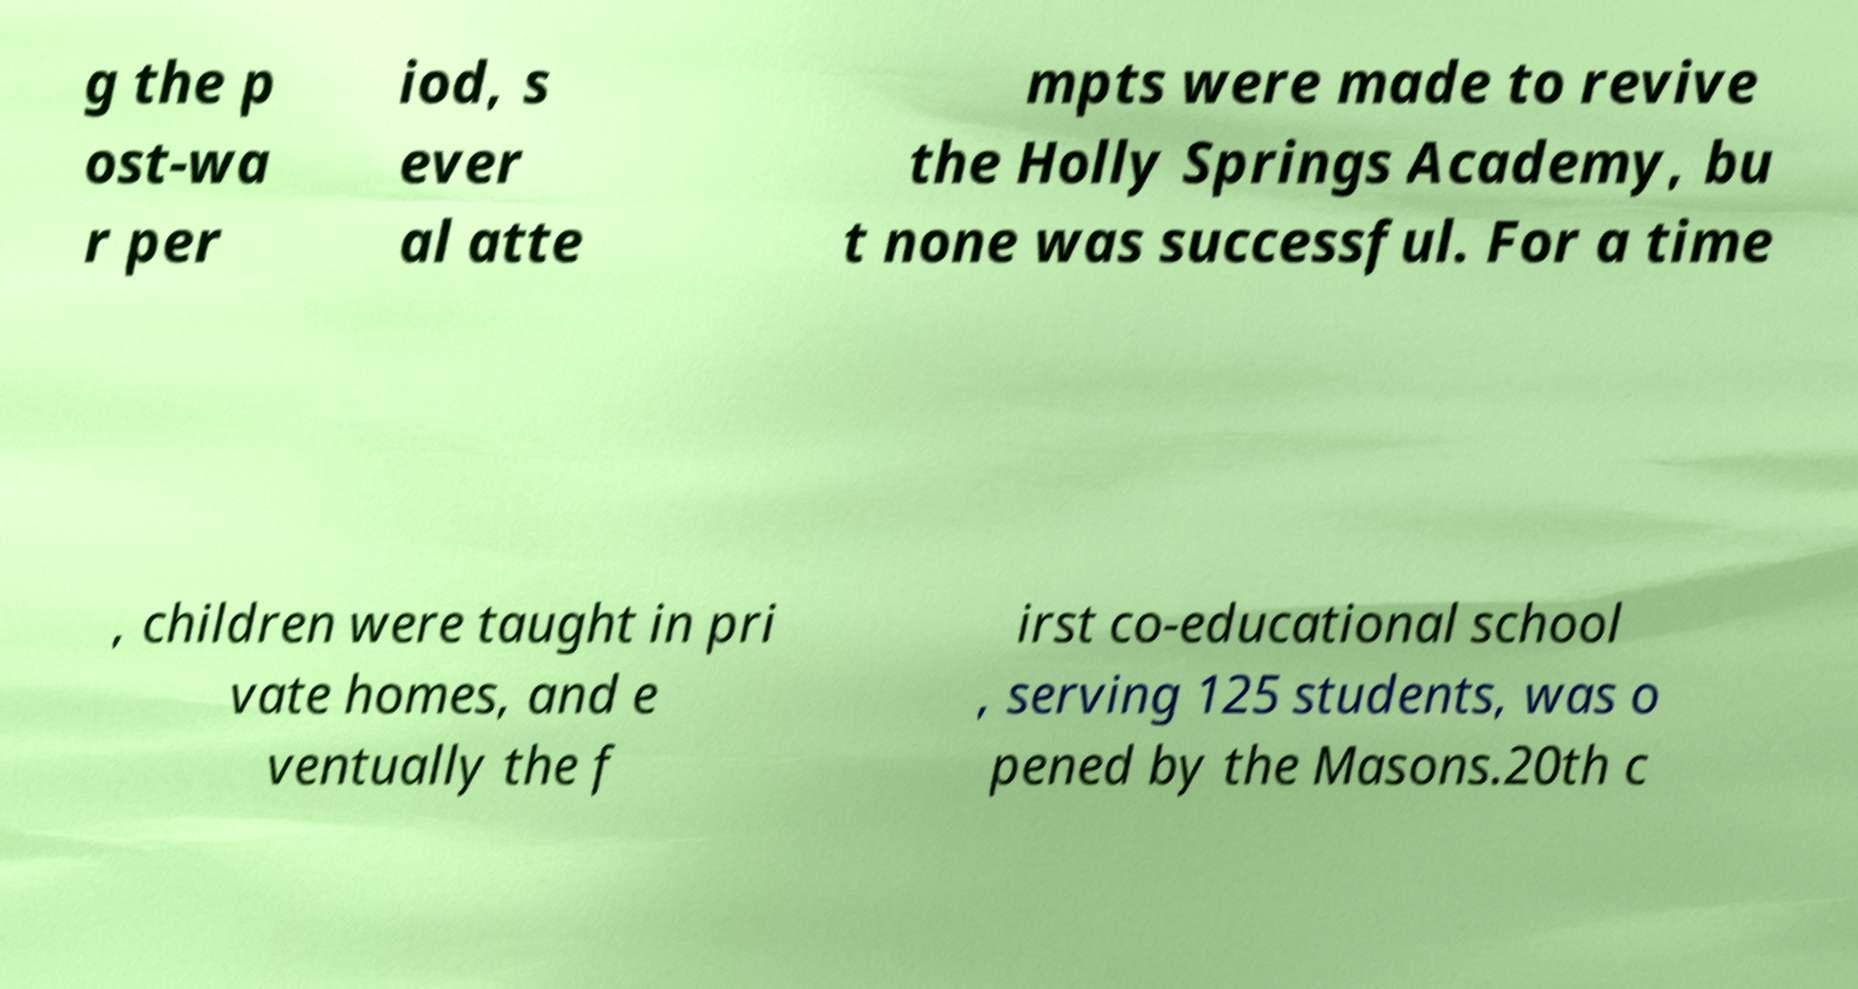Could you extract and type out the text from this image? g the p ost-wa r per iod, s ever al atte mpts were made to revive the Holly Springs Academy, bu t none was successful. For a time , children were taught in pri vate homes, and e ventually the f irst co-educational school , serving 125 students, was o pened by the Masons.20th c 